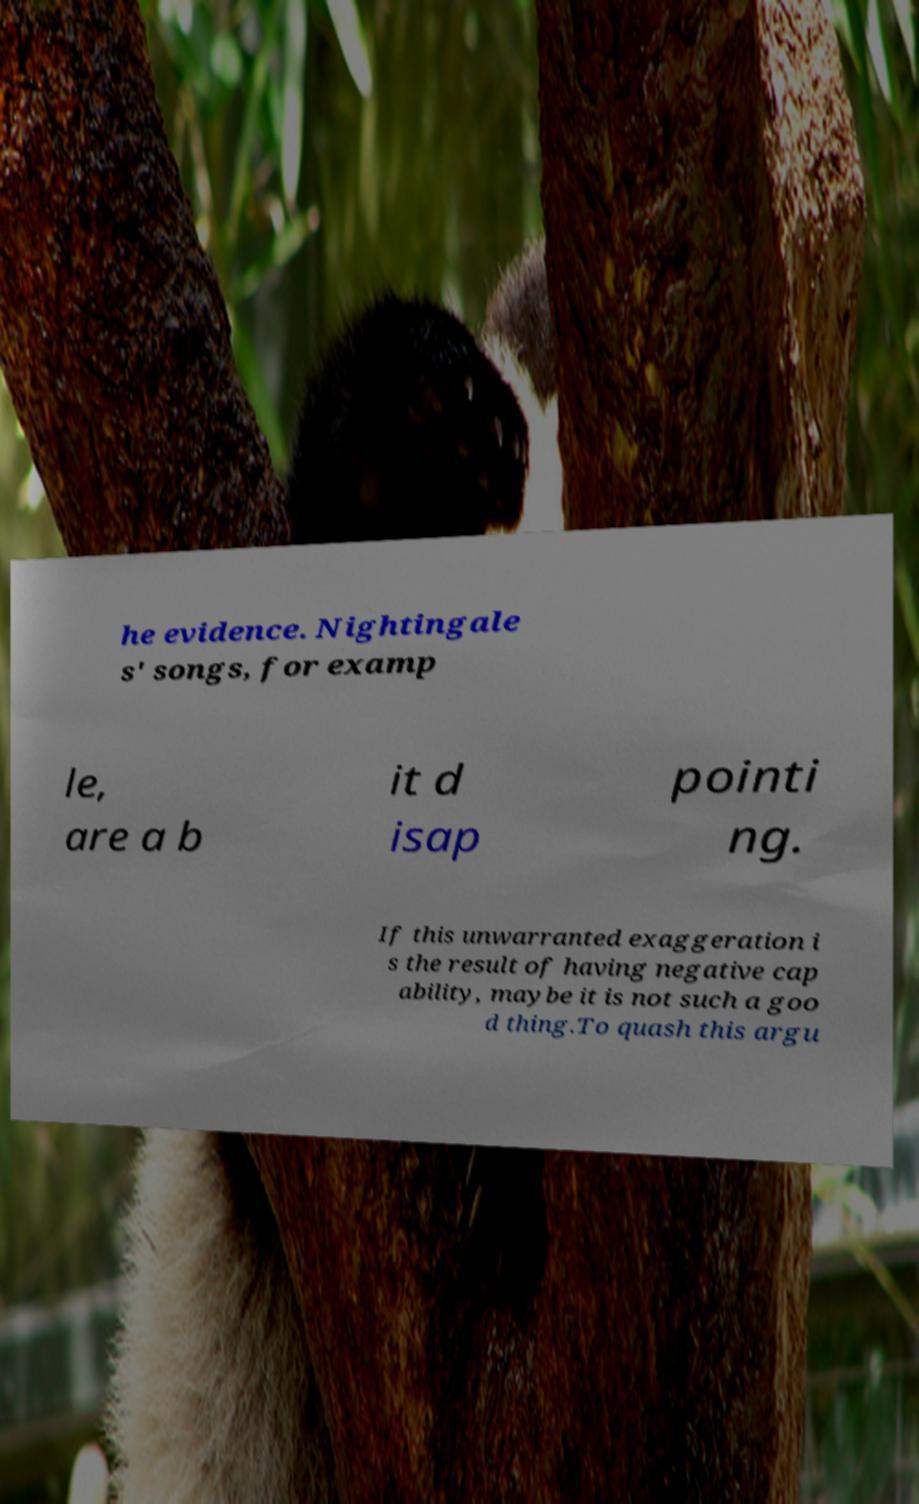Could you assist in decoding the text presented in this image and type it out clearly? he evidence. Nightingale s' songs, for examp le, are a b it d isap pointi ng. If this unwarranted exaggeration i s the result of having negative cap ability, maybe it is not such a goo d thing.To quash this argu 